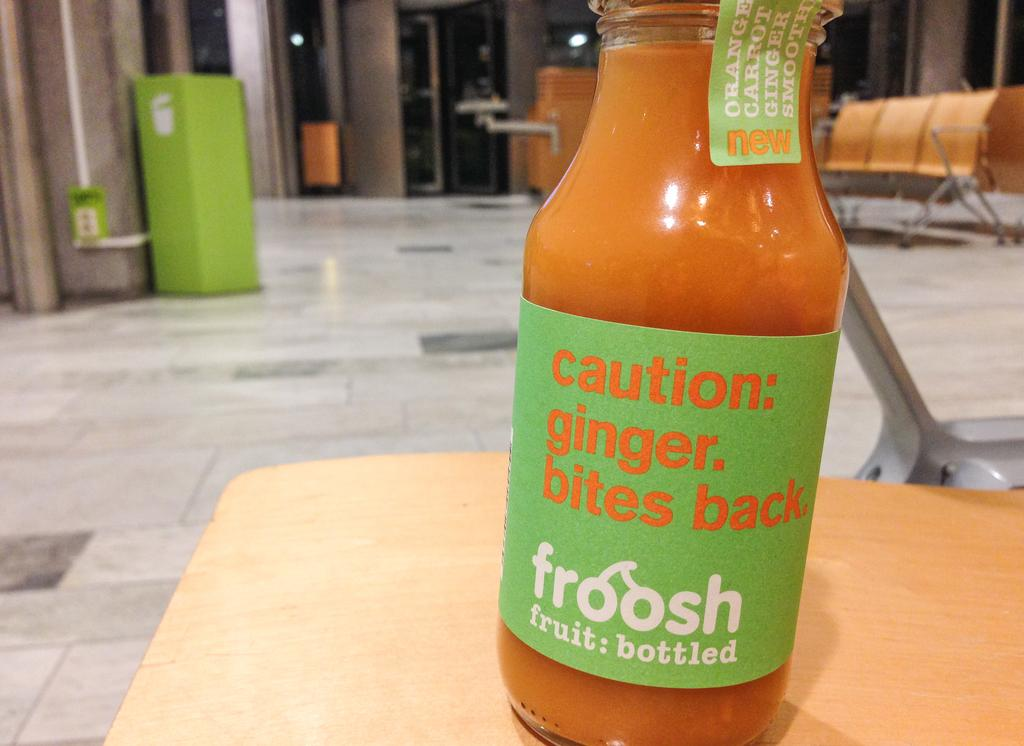<image>
Render a clear and concise summary of the photo. a bottle of ginger with a green caution label on it 